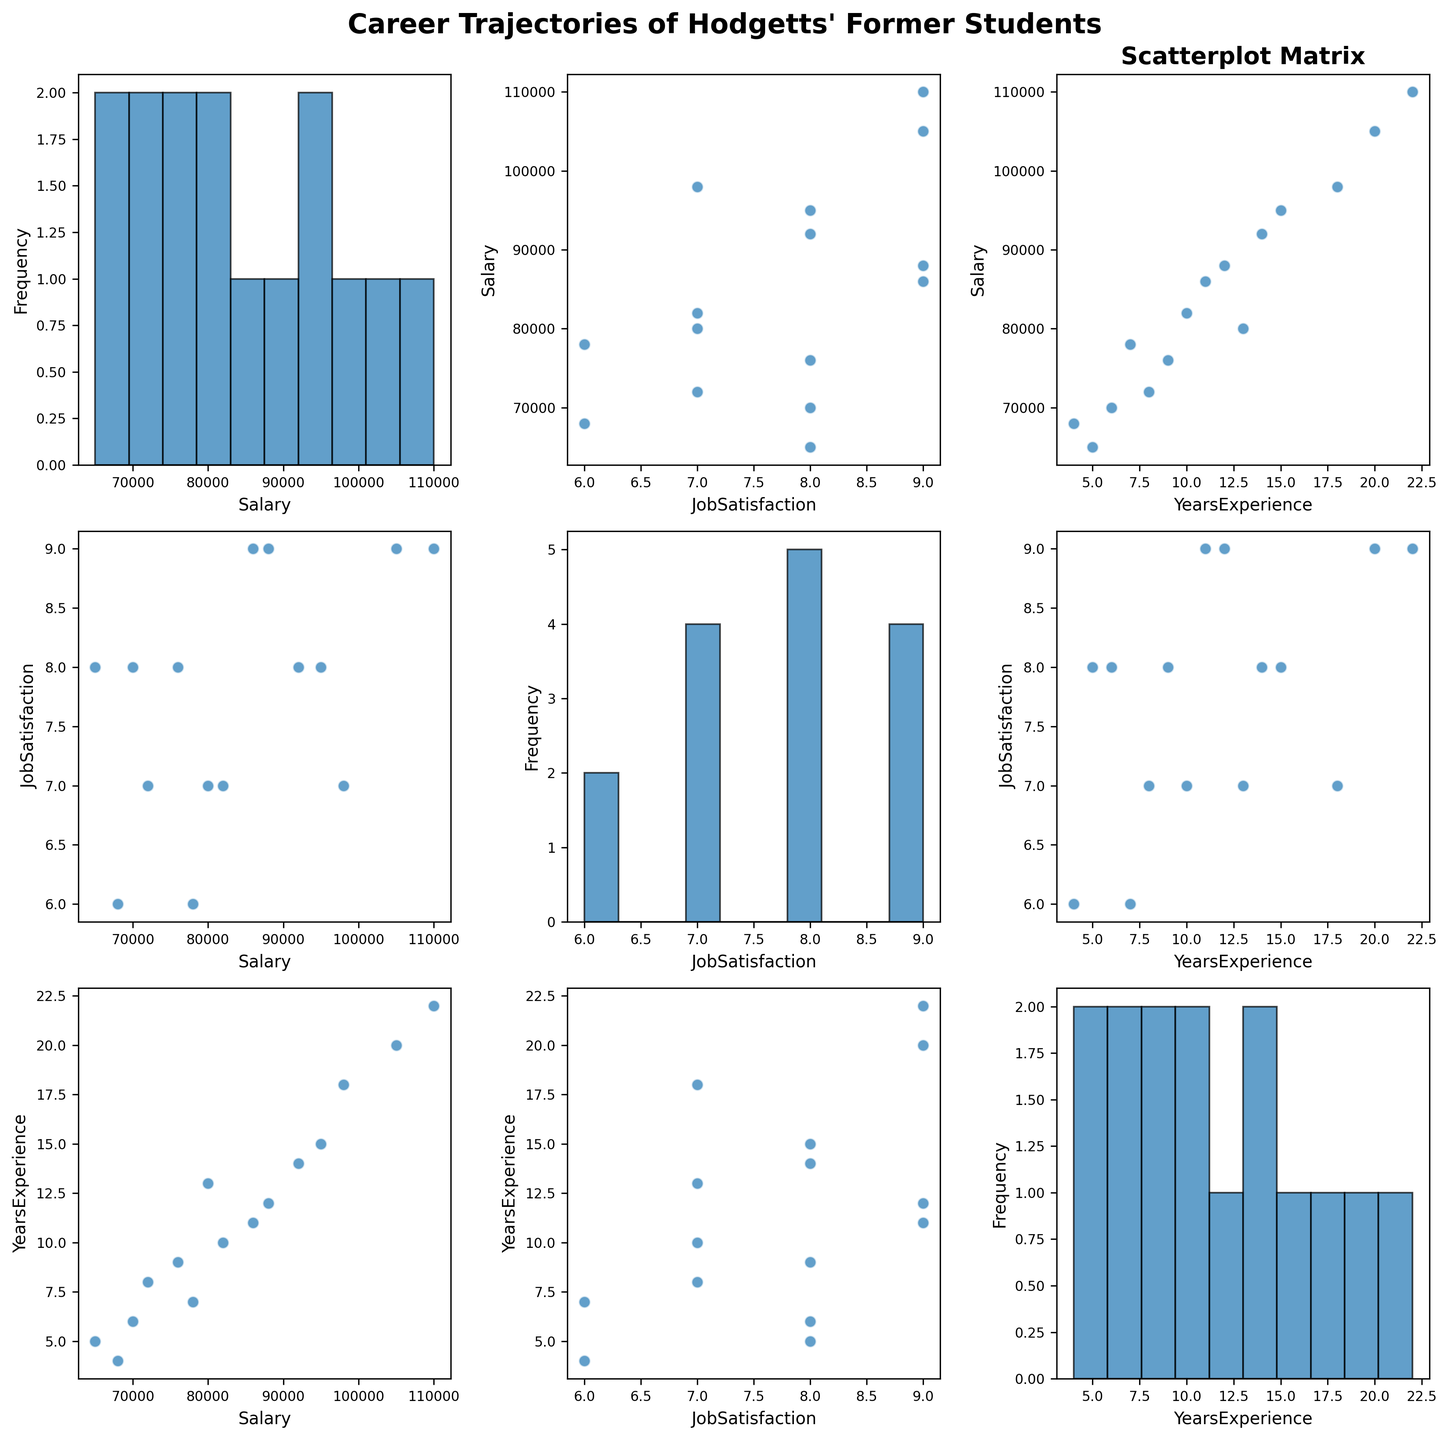What is the title of the figure? The title is located at the top of the figure and provides a summary of what the figure shows. Upon examining the top of the figure, we see the title "Career Trajectories of Hodgetts' Former Students".
Answer: Career Trajectories of Hodgetts' Former Students How many variables are visualized in the scatterplot matrix? The plot shows relationships between different variables. Each axis label indicates a distinct variable: Salary, Job Satisfaction, and Years of Experience, totaling to three variables.
Answer: 3 Which two variables are being compared in the bottom-left scatter plot? In the scatterplot matrix, the bottom-left plot has 'YearsExperience' on the x-axis and 'Salary' on the y-axis.
Answer: YearsExperience and Salary For the variable 'YearsExperience', what is more frequent: values below 10 years or above 10 years? By examining the histogram diagonally in the scatterplot matrix for 'YearsExperience', count the frequency of values on either side of the 10-year mark. Visual analysis shows there are more bars representing data points below 10 years than above.
Answer: below 10 years Is there a noticeable trend in the scatter plot comparing Salary and Job Satisfaction? In the scatterplot matrix, observe the plot where 'Salary' is on one axis and 'JobSatisfaction' on the other. The data points do not form a clear linear trend, indicating no strong correlation where higher salaries consistently lead to higher job satisfaction.
Answer: No noticeable trend How does the spread of Salary compare to Job Satisfaction? Compare the range and distribution of the histograms for 'Salary' and 'JobSatisfaction'. 'Salary' shows wider variance due to higher differences in amounts, whereas 'JobSatisfaction' is comparatively concentrated.
Answer: Salary has a wider spread Looking at the scatter plots involving YearsExperience, does experience appear to correlate with Salary? In the scatterplot matrix, observe the plot with 'YearsExperience' on the x-axis and 'Salary' on the y-axis. The data points trend upward, indicating a positive correlation where more experience tends to correspond to higher salary.
Answer: Yes Among the scatter plots, which comparison shows the least correlation? By visual inspection, the scatter plot with 'Salary' against 'JobSatisfaction' reveals the least amount of clustering or trend, suggesting lower correlation compared to other variables.
Answer: Salary and Job Satisfaction How many students have a Job Satisfaction score of 8? Look at the histogram for 'JobSatisfaction' and count the bars corresponding to a score of 8. There are five students with this score.
Answer: 5 